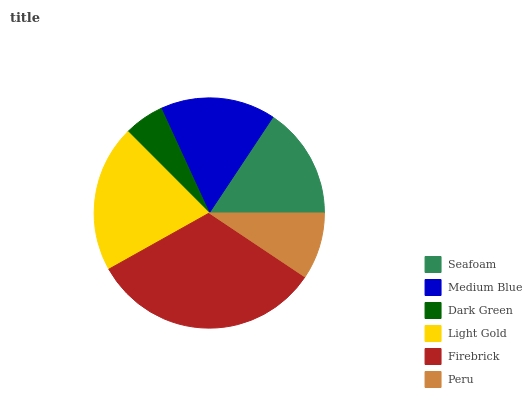Is Dark Green the minimum?
Answer yes or no. Yes. Is Firebrick the maximum?
Answer yes or no. Yes. Is Medium Blue the minimum?
Answer yes or no. No. Is Medium Blue the maximum?
Answer yes or no. No. Is Medium Blue greater than Seafoam?
Answer yes or no. Yes. Is Seafoam less than Medium Blue?
Answer yes or no. Yes. Is Seafoam greater than Medium Blue?
Answer yes or no. No. Is Medium Blue less than Seafoam?
Answer yes or no. No. Is Medium Blue the high median?
Answer yes or no. Yes. Is Seafoam the low median?
Answer yes or no. Yes. Is Light Gold the high median?
Answer yes or no. No. Is Light Gold the low median?
Answer yes or no. No. 